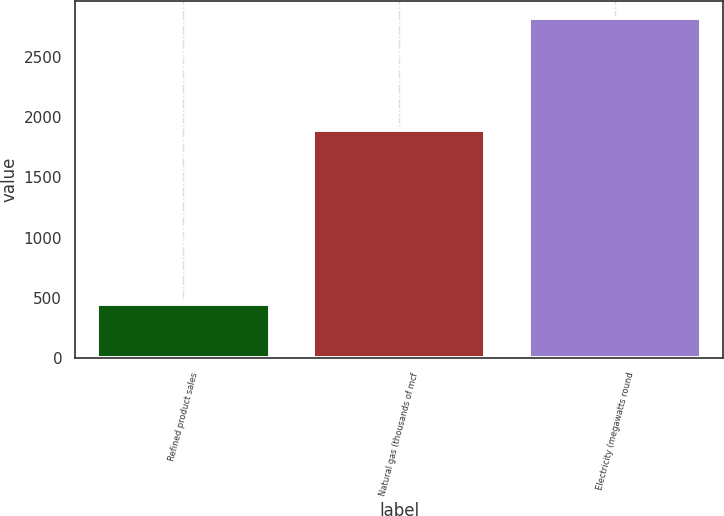Convert chart. <chart><loc_0><loc_0><loc_500><loc_500><bar_chart><fcel>Refined product sales<fcel>Natural gas (thousands of mcf<fcel>Electricity (megawatts round<nl><fcel>451<fcel>1890<fcel>2821<nl></chart> 